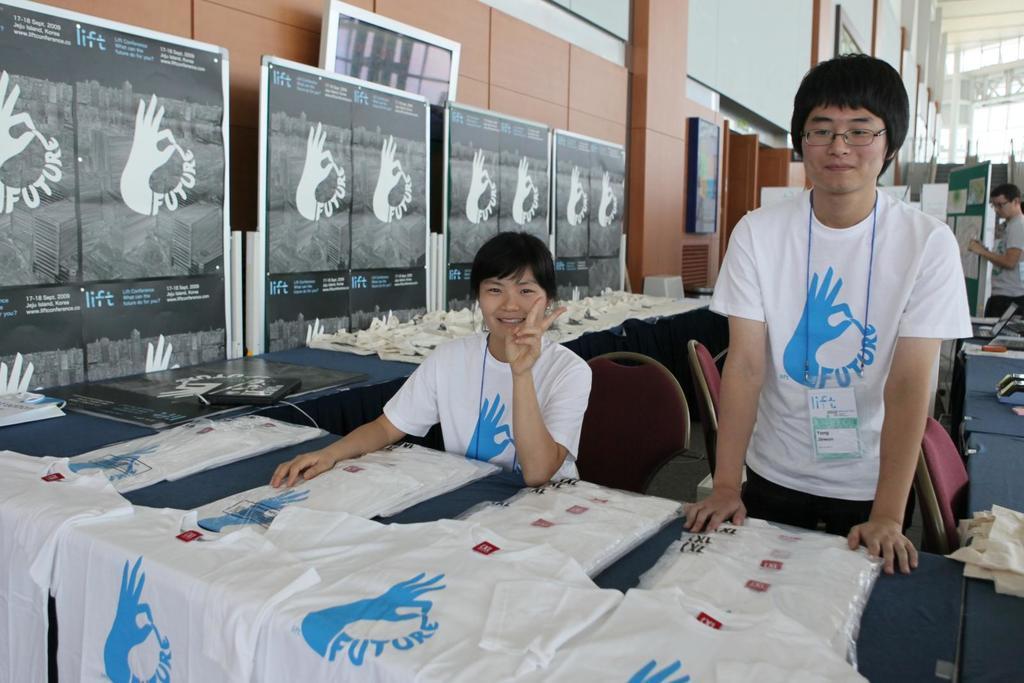Describe this image in one or two sentences. In this image, there is a table contains some t-shirts. There is a person in the middle of the image sitting on the chair in front of the table. There is a person on the right side of the image standing in front of the table. There are some boards in the top left of the image. 